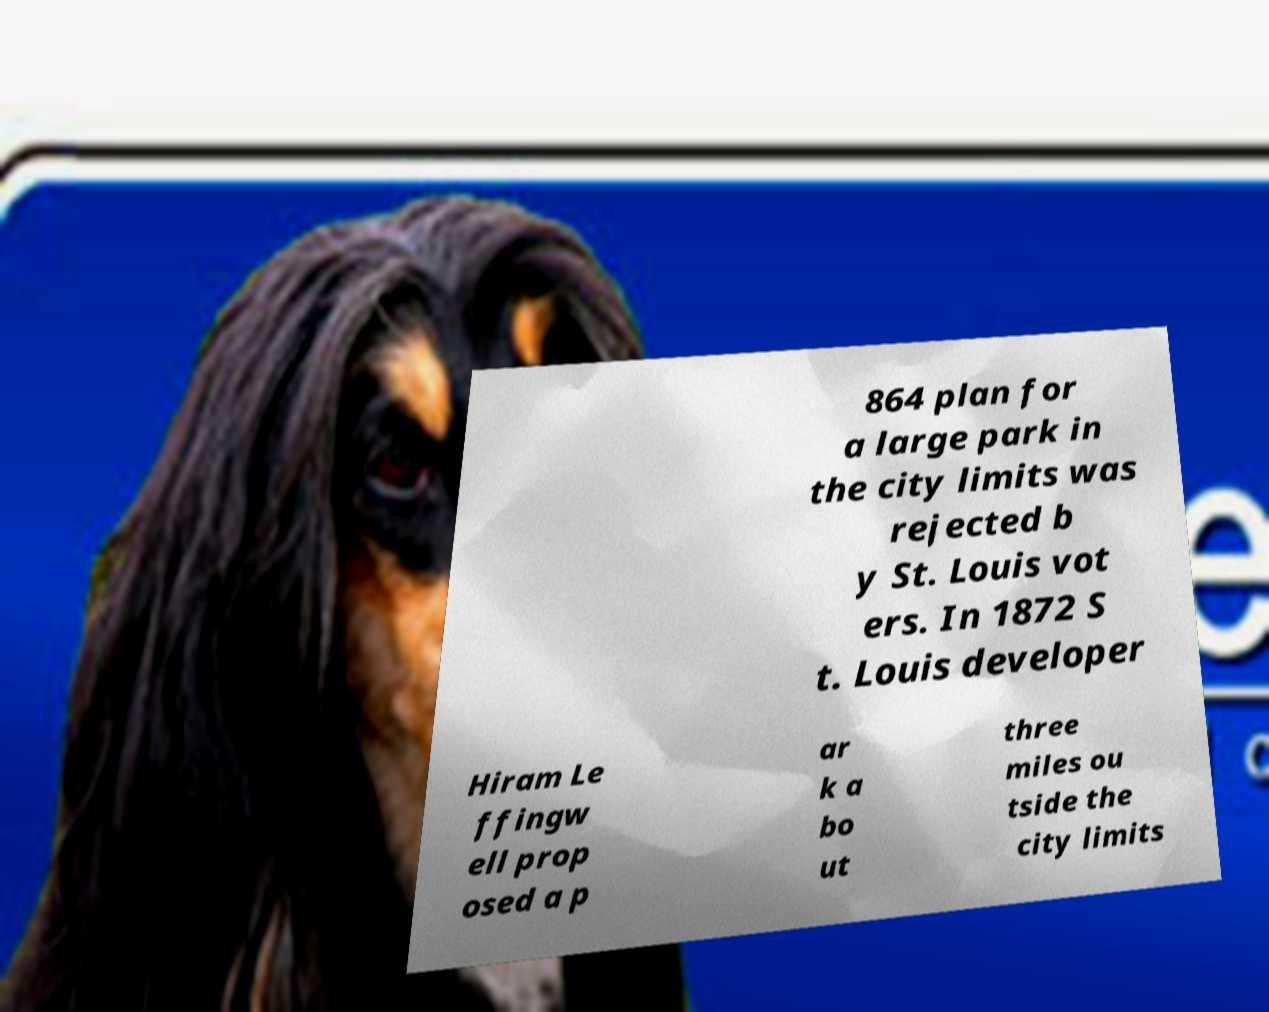Can you read and provide the text displayed in the image?This photo seems to have some interesting text. Can you extract and type it out for me? 864 plan for a large park in the city limits was rejected b y St. Louis vot ers. In 1872 S t. Louis developer Hiram Le ffingw ell prop osed a p ar k a bo ut three miles ou tside the city limits 